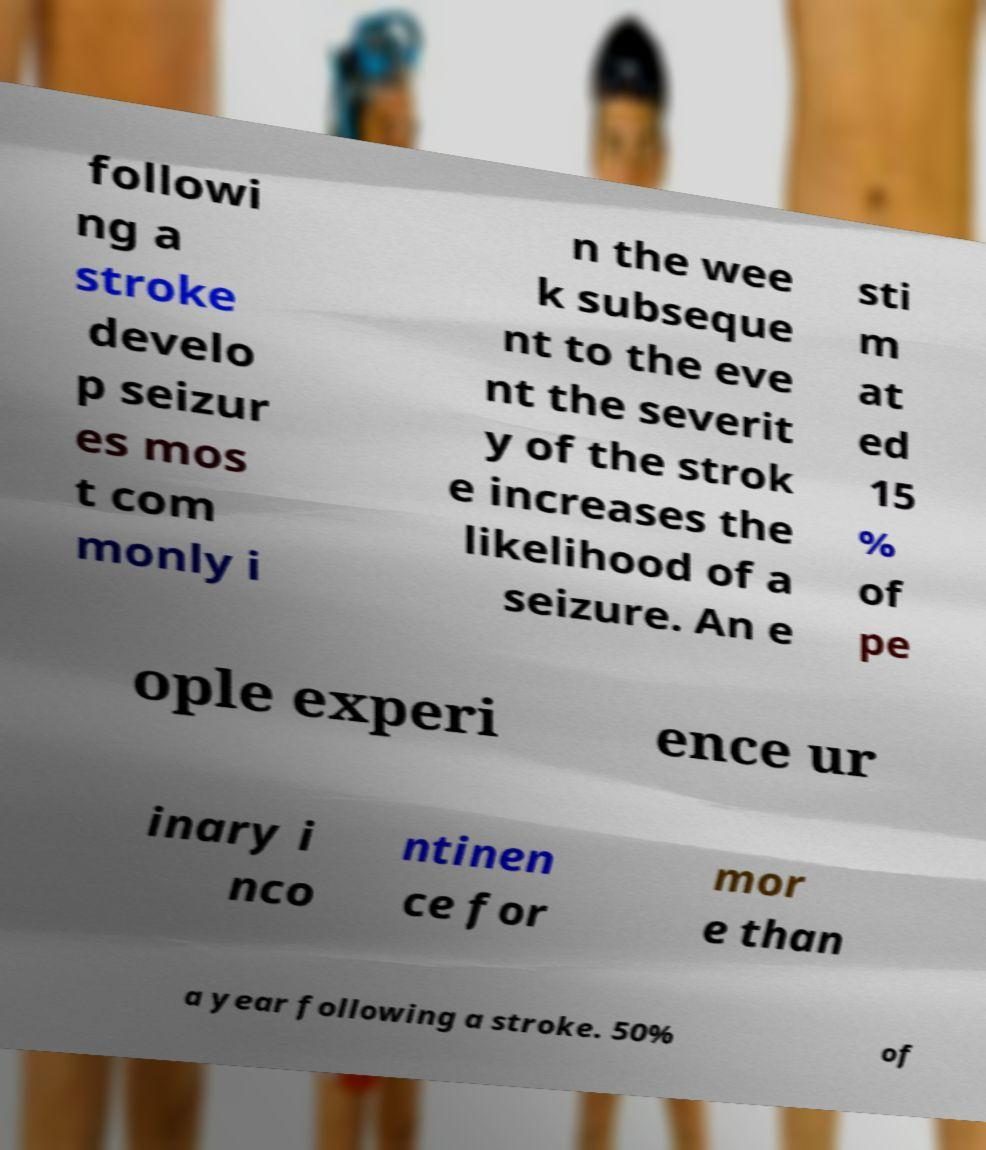Could you assist in decoding the text presented in this image and type it out clearly? followi ng a stroke develo p seizur es mos t com monly i n the wee k subseque nt to the eve nt the severit y of the strok e increases the likelihood of a seizure. An e sti m at ed 15 % of pe ople experi ence ur inary i nco ntinen ce for mor e than a year following a stroke. 50% of 